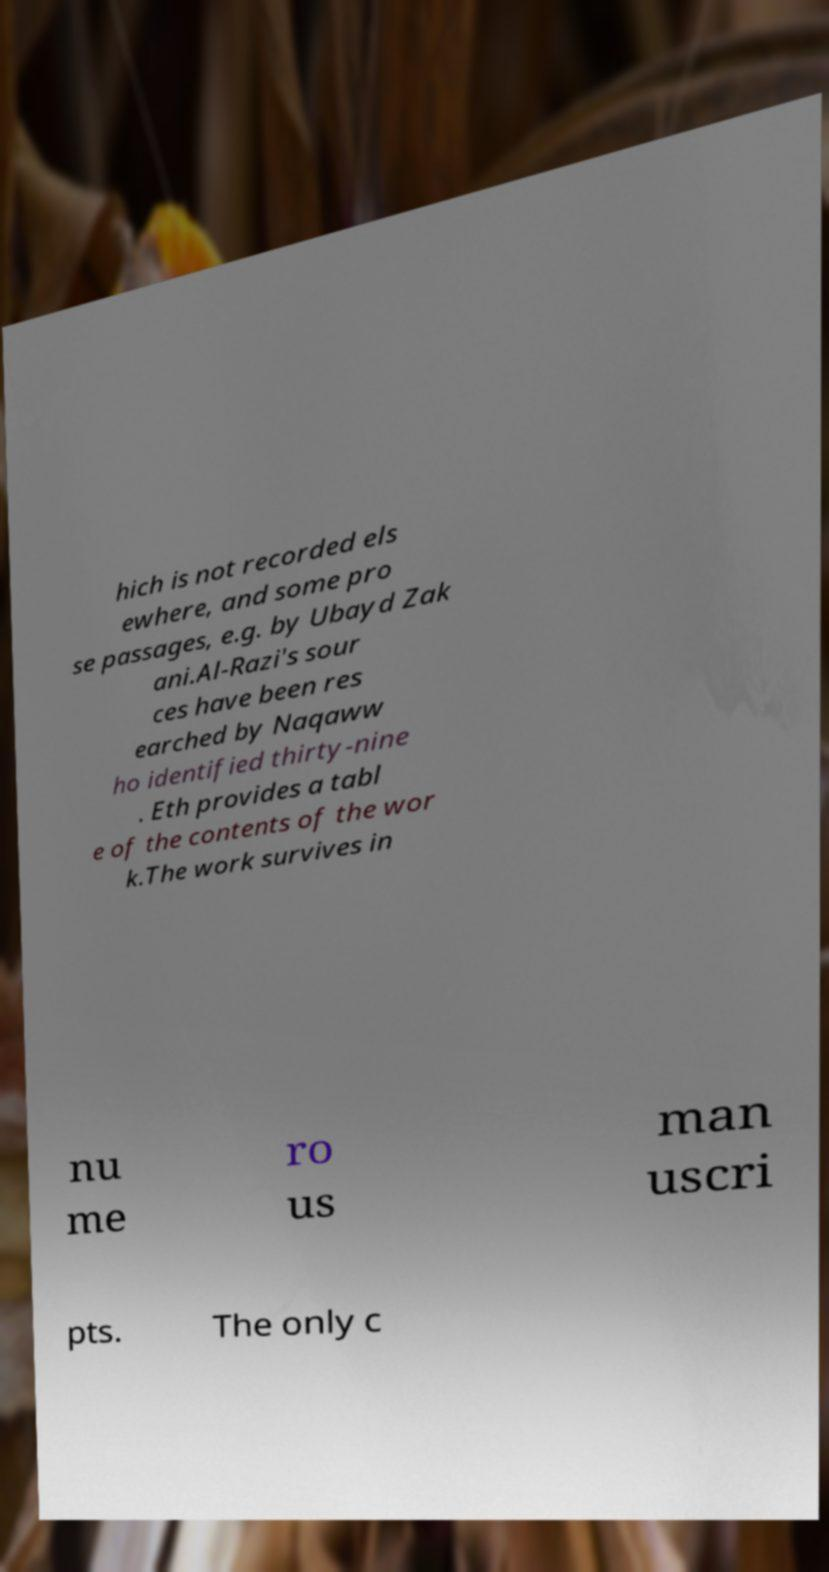Please identify and transcribe the text found in this image. hich is not recorded els ewhere, and some pro se passages, e.g. by Ubayd Zak ani.Al-Razi's sour ces have been res earched by Naqaww ho identified thirty-nine . Eth provides a tabl e of the contents of the wor k.The work survives in nu me ro us man uscri pts. The only c 